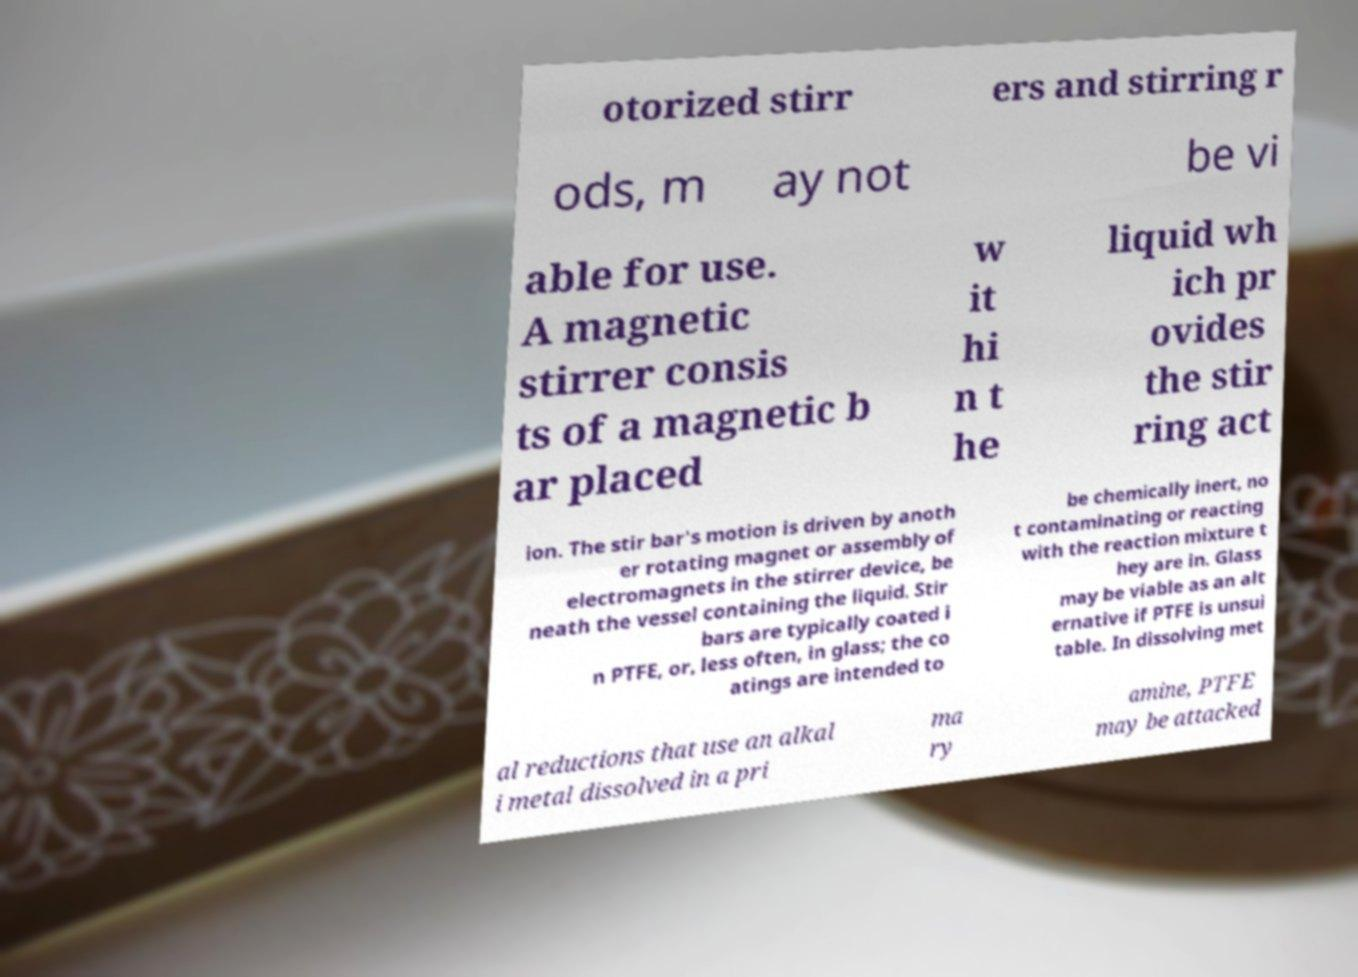Could you extract and type out the text from this image? otorized stirr ers and stirring r ods, m ay not be vi able for use. A magnetic stirrer consis ts of a magnetic b ar placed w it hi n t he liquid wh ich pr ovides the stir ring act ion. The stir bar's motion is driven by anoth er rotating magnet or assembly of electromagnets in the stirrer device, be neath the vessel containing the liquid. Stir bars are typically coated i n PTFE, or, less often, in glass; the co atings are intended to be chemically inert, no t contaminating or reacting with the reaction mixture t hey are in. Glass may be viable as an alt ernative if PTFE is unsui table. In dissolving met al reductions that use an alkal i metal dissolved in a pri ma ry amine, PTFE may be attacked 